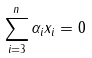<formula> <loc_0><loc_0><loc_500><loc_500>\sum _ { i = 3 } ^ { n } \alpha _ { i } x _ { i } = 0</formula> 